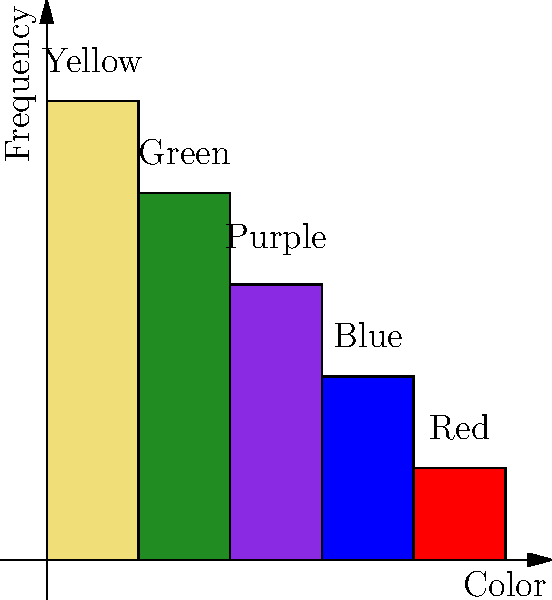In ancient Egyptian tomb paintings, which color was most frequently used according to the graph, and what symbolic significance might this have had in Egyptian culture? To answer this question, we need to analyze the graph and apply our knowledge of ancient Egyptian symbolism:

1. The graph shows the frequency of different colors used in ancient Egyptian tomb paintings.

2. The colors are represented by bars of different heights, with taller bars indicating higher frequency of use.

3. From left to right, we see:
   - Yellow: tallest bar (height 5)
   - Green: second tallest (height 4)
   - Purple: third (height 3)
   - Blue: fourth (height 2)
   - Red: shortest (height 1)

4. The tallest bar corresponds to yellow, indicating it was the most frequently used color.

5. In ancient Egyptian symbolism, yellow was associated with:
   - The sun and solar deities (e.g., Ra)
   - Eternity and immortality
   - Gold, which was considered the flesh of the gods

6. The frequent use of yellow in tomb paintings likely reflects:
   - The importance of sun worship in Egyptian religion
   - The desire for eternal life and protection in the afterlife
   - The association with divine power and immortality

Therefore, the most frequently used color was yellow, symbolizing the sun, eternity, and divine power in ancient Egyptian culture.
Answer: Yellow; symbolizing sun, eternity, and divinity 